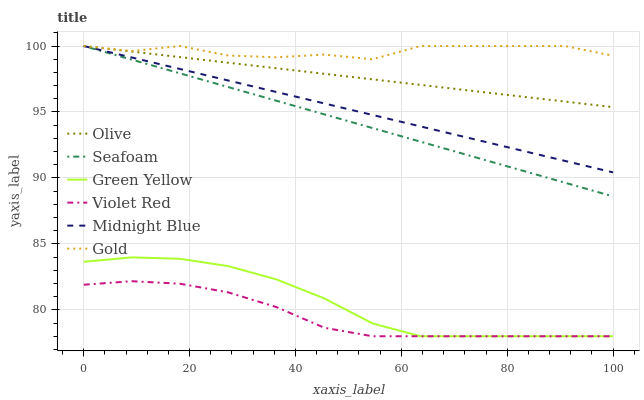Does Violet Red have the minimum area under the curve?
Answer yes or no. Yes. Does Gold have the maximum area under the curve?
Answer yes or no. Yes. Does Midnight Blue have the minimum area under the curve?
Answer yes or no. No. Does Midnight Blue have the maximum area under the curve?
Answer yes or no. No. Is Midnight Blue the smoothest?
Answer yes or no. Yes. Is Gold the roughest?
Answer yes or no. Yes. Is Gold the smoothest?
Answer yes or no. No. Is Midnight Blue the roughest?
Answer yes or no. No. Does Violet Red have the lowest value?
Answer yes or no. Yes. Does Midnight Blue have the lowest value?
Answer yes or no. No. Does Olive have the highest value?
Answer yes or no. Yes. Does Green Yellow have the highest value?
Answer yes or no. No. Is Green Yellow less than Gold?
Answer yes or no. Yes. Is Gold greater than Violet Red?
Answer yes or no. Yes. Does Gold intersect Midnight Blue?
Answer yes or no. Yes. Is Gold less than Midnight Blue?
Answer yes or no. No. Is Gold greater than Midnight Blue?
Answer yes or no. No. Does Green Yellow intersect Gold?
Answer yes or no. No. 